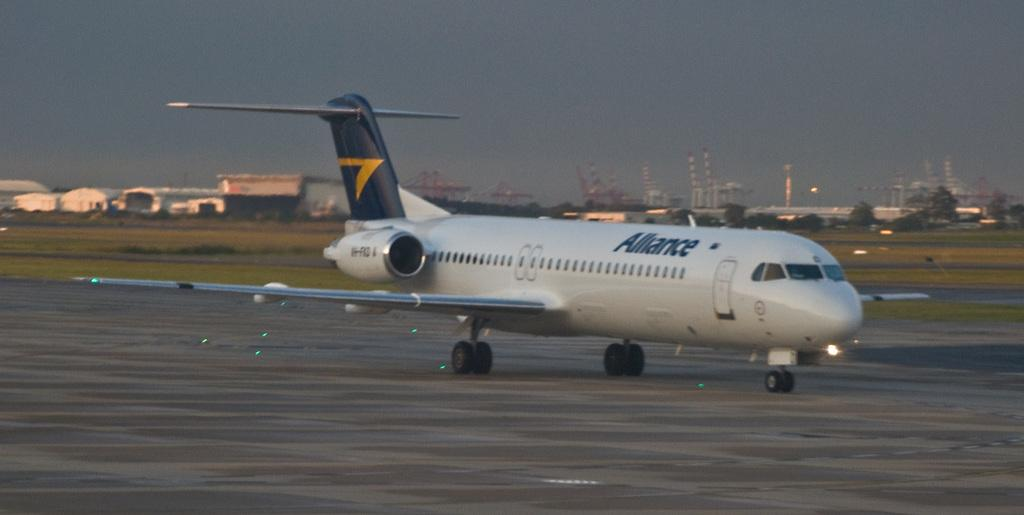<image>
Summarize the visual content of the image. An Alliance airplane is on the runway at the airport. 